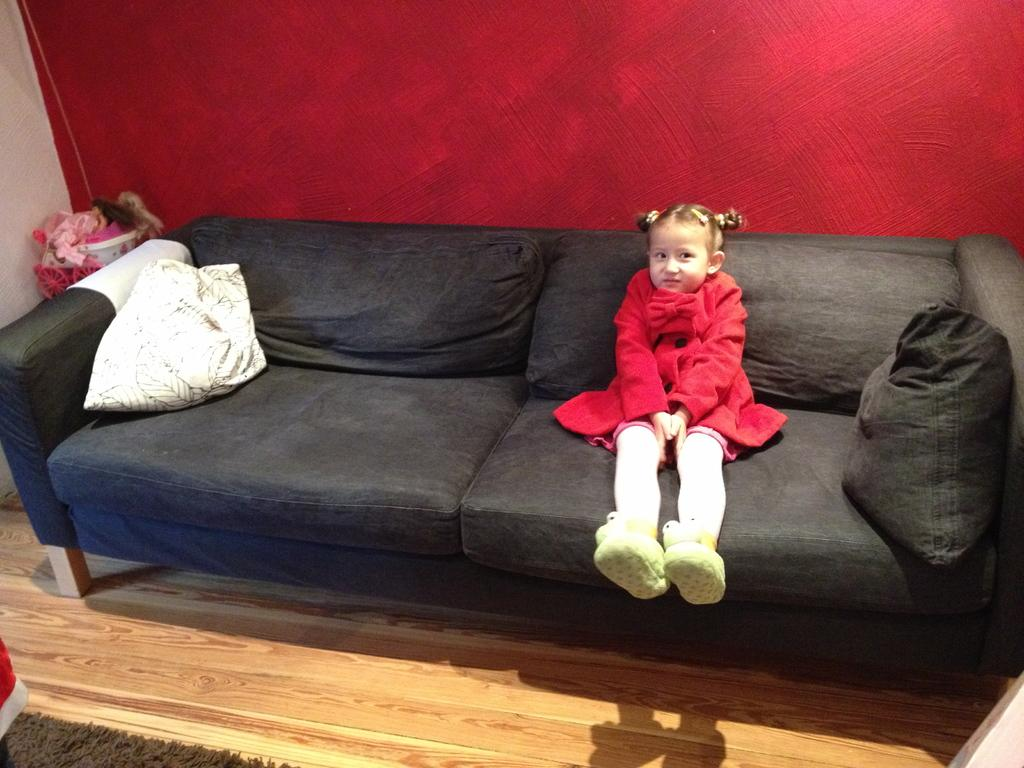Who is the main subject in the image? There is a girl in the image. What is the girl doing in the image? The girl is sitting on a sofa. Can you describe the sofa in the image? The sofa is black in color, and there are pillows on it. What can be seen in the background of the image? There is a red-colored wall in the background. What type of school can be seen in the image? There is no school present in the image; it features a girl sitting on a black sofa with pillows and a red-colored wall in the background. 